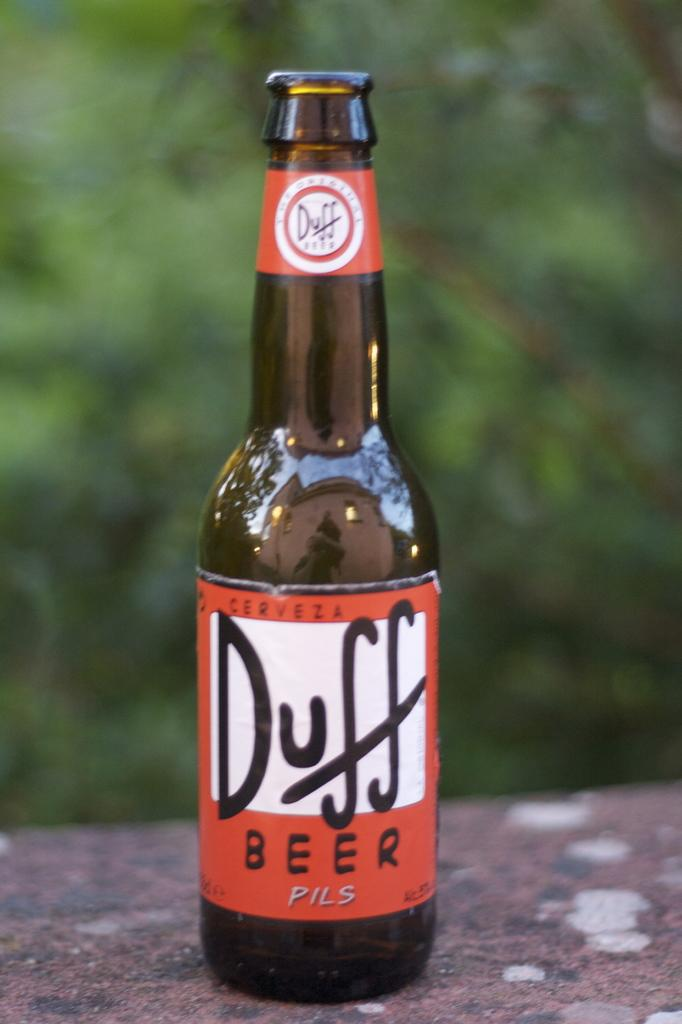<image>
Create a compact narrative representing the image presented. An open bottle of Duff beer which is a pils. 